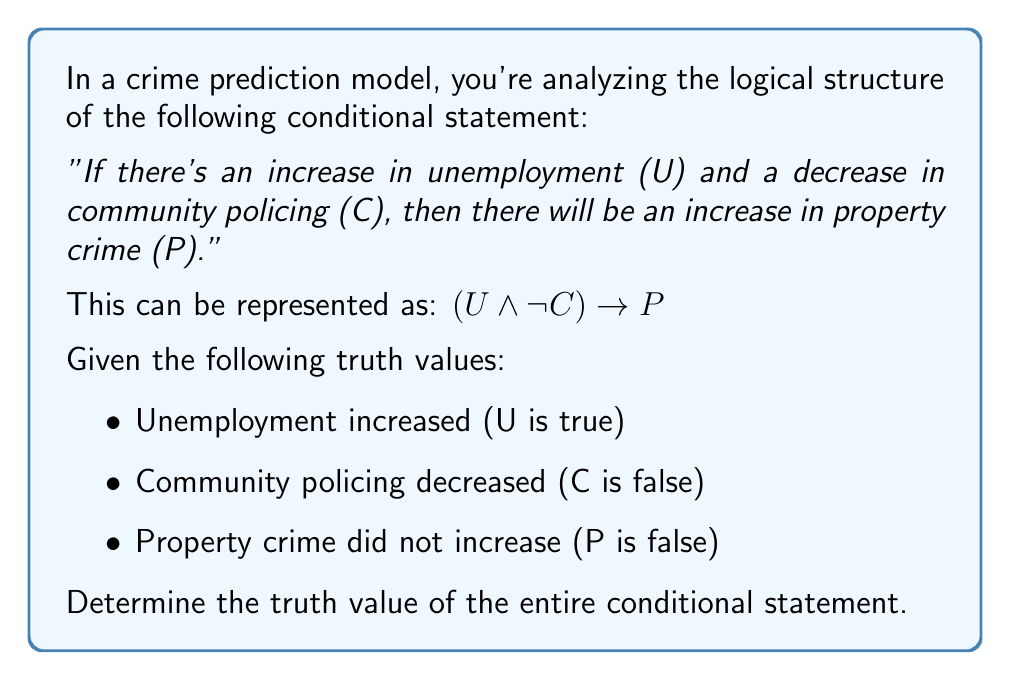Solve this math problem. Let's approach this step-by-step:

1) First, let's recall the truth table for the conditional statement $A \rightarrow B$:

   | A | B | A → B |
   |---|---|-------|
   | T | T |   T   |
   | T | F |   F   |
   | F | T |   T   |
   | F | F |   T   |

2) In our case, $(U \land \lnot C)$ is the antecedent (A) and $P$ is the consequent (B).

3) Let's evaluate the antecedent $(U \land \lnot C)$:
   - U is true
   - C is false, so $\lnot C$ is true
   - $U \land \lnot C$ is true $\land$ true = true

4) Now we have:
   - Antecedent $(U \land \lnot C)$ is true
   - Consequent $P$ is false

5) Referring to the truth table, when the antecedent is true and the consequent is false, the conditional statement is false.

Therefore, the entire conditional statement $(U \land \lnot C) \rightarrow P$ is false in this scenario.
Answer: False 